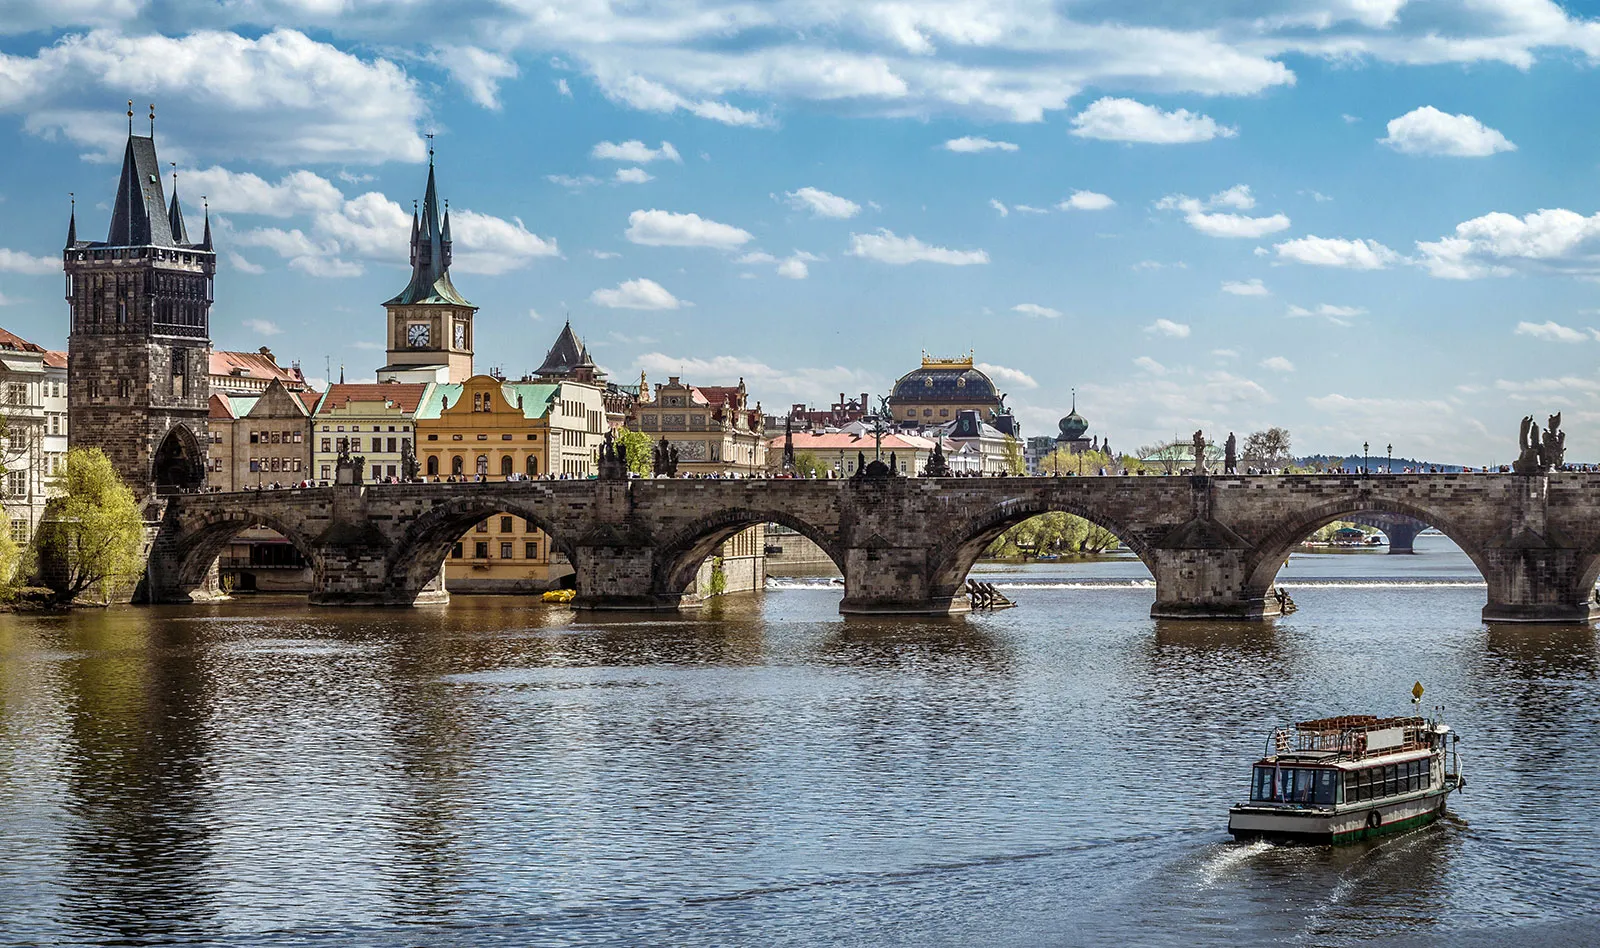What historical events have taken place on the Charles Bridge? Charles Bridge has witnessed numerous historical events since its construction in the 14th century. It was crucial during the Hussite Wars and saw several skirmishes and hostile occupations. In more peaceful times, it has been the center of many cultural events and royal processions, embodying Prague's historical and cultural evolution. 